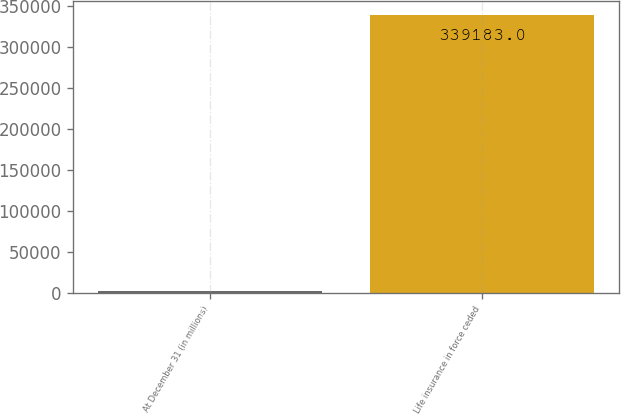<chart> <loc_0><loc_0><loc_500><loc_500><bar_chart><fcel>At December 31 (in millions)<fcel>Life insurance in force ceded<nl><fcel>2009<fcel>339183<nl></chart> 